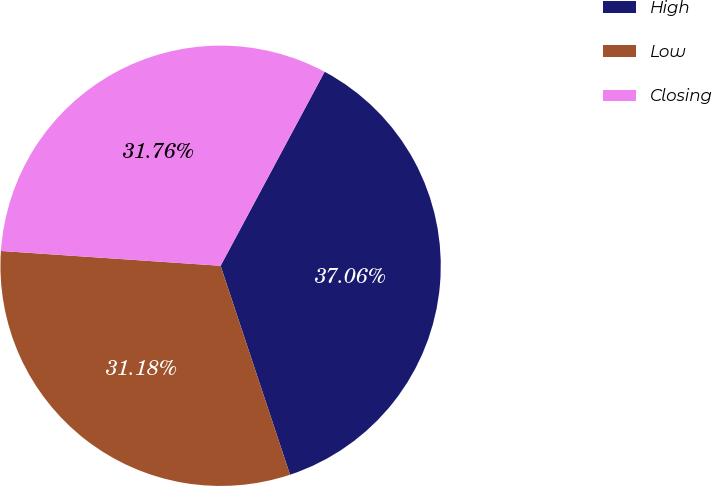<chart> <loc_0><loc_0><loc_500><loc_500><pie_chart><fcel>High<fcel>Low<fcel>Closing<nl><fcel>37.06%<fcel>31.18%<fcel>31.76%<nl></chart> 